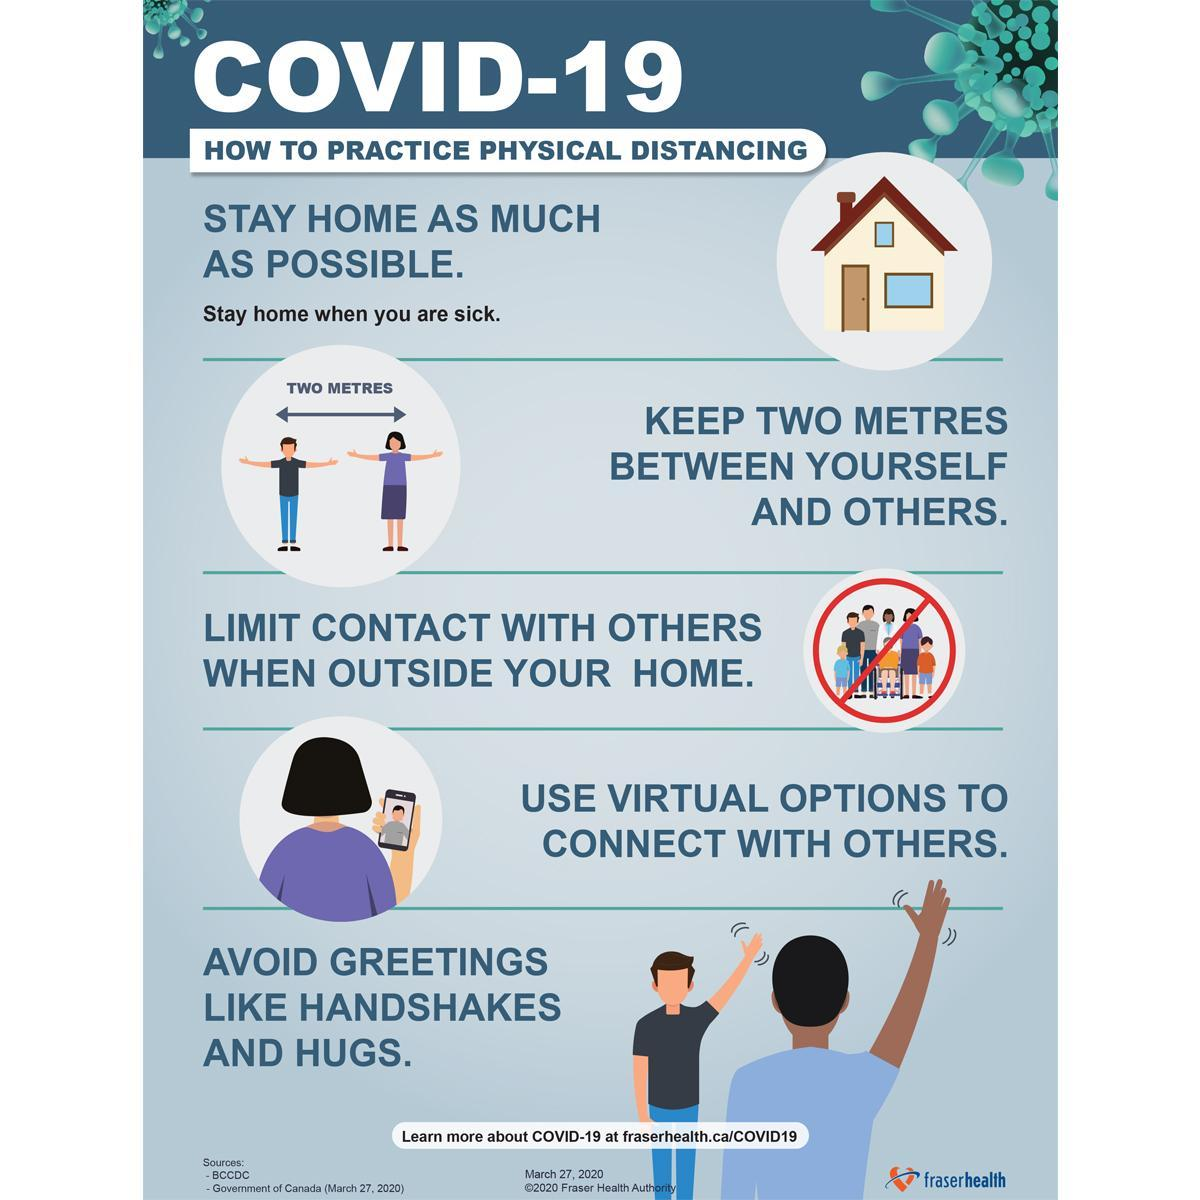What should be avoided while social distancing, staying home, limiting contact or virtually connecting with others?
Answer the question with a short phrase. limiting contact What is the distance between the man and the woman? TWO METRES 